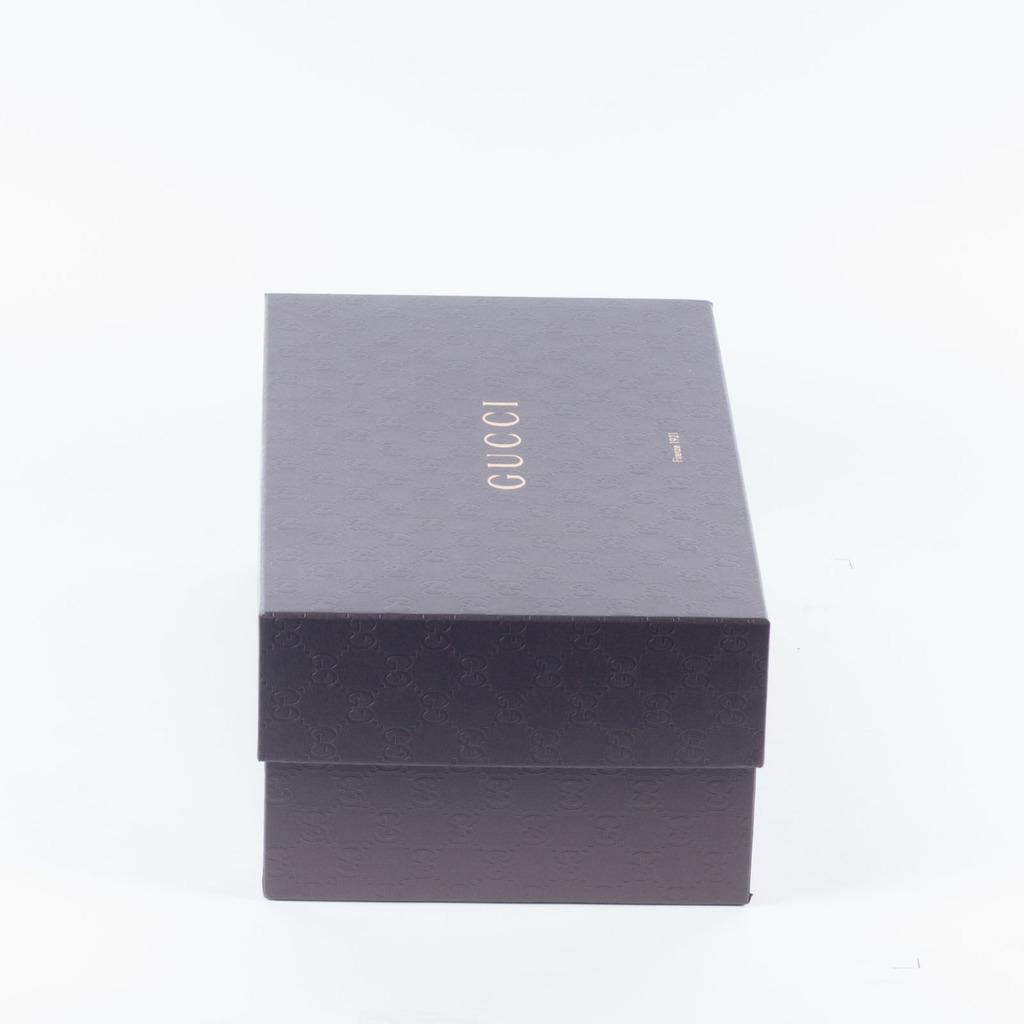<image>
Describe the image concisely. a box for Gucci is on a white surface 